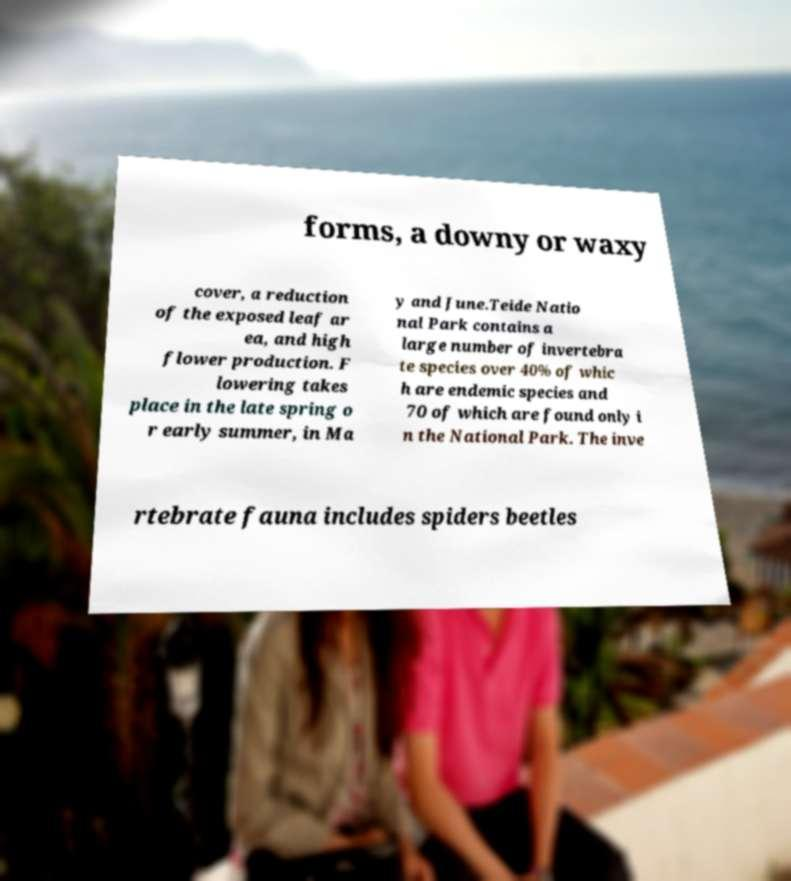Could you extract and type out the text from this image? forms, a downy or waxy cover, a reduction of the exposed leaf ar ea, and high flower production. F lowering takes place in the late spring o r early summer, in Ma y and June.Teide Natio nal Park contains a large number of invertebra te species over 40% of whic h are endemic species and 70 of which are found only i n the National Park. The inve rtebrate fauna includes spiders beetles 